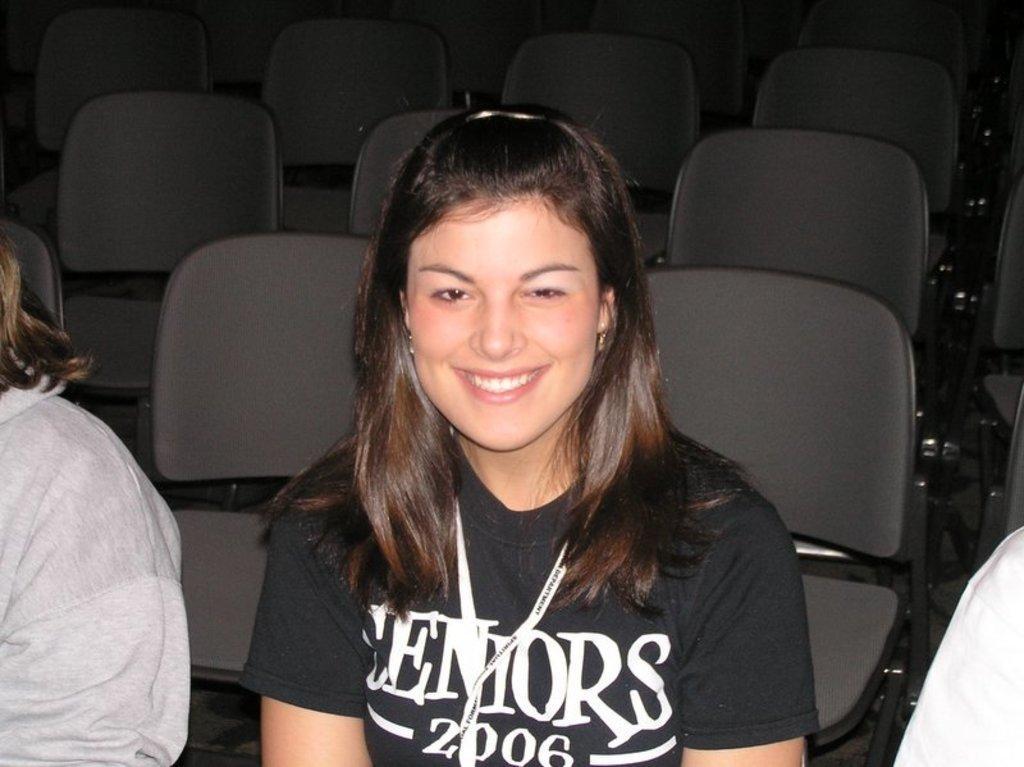Please provide a concise description of this image. In this image there are three people sitting on the chairs. In the center there is a woman sitting. She is smiling. Behind them there are chairs. 